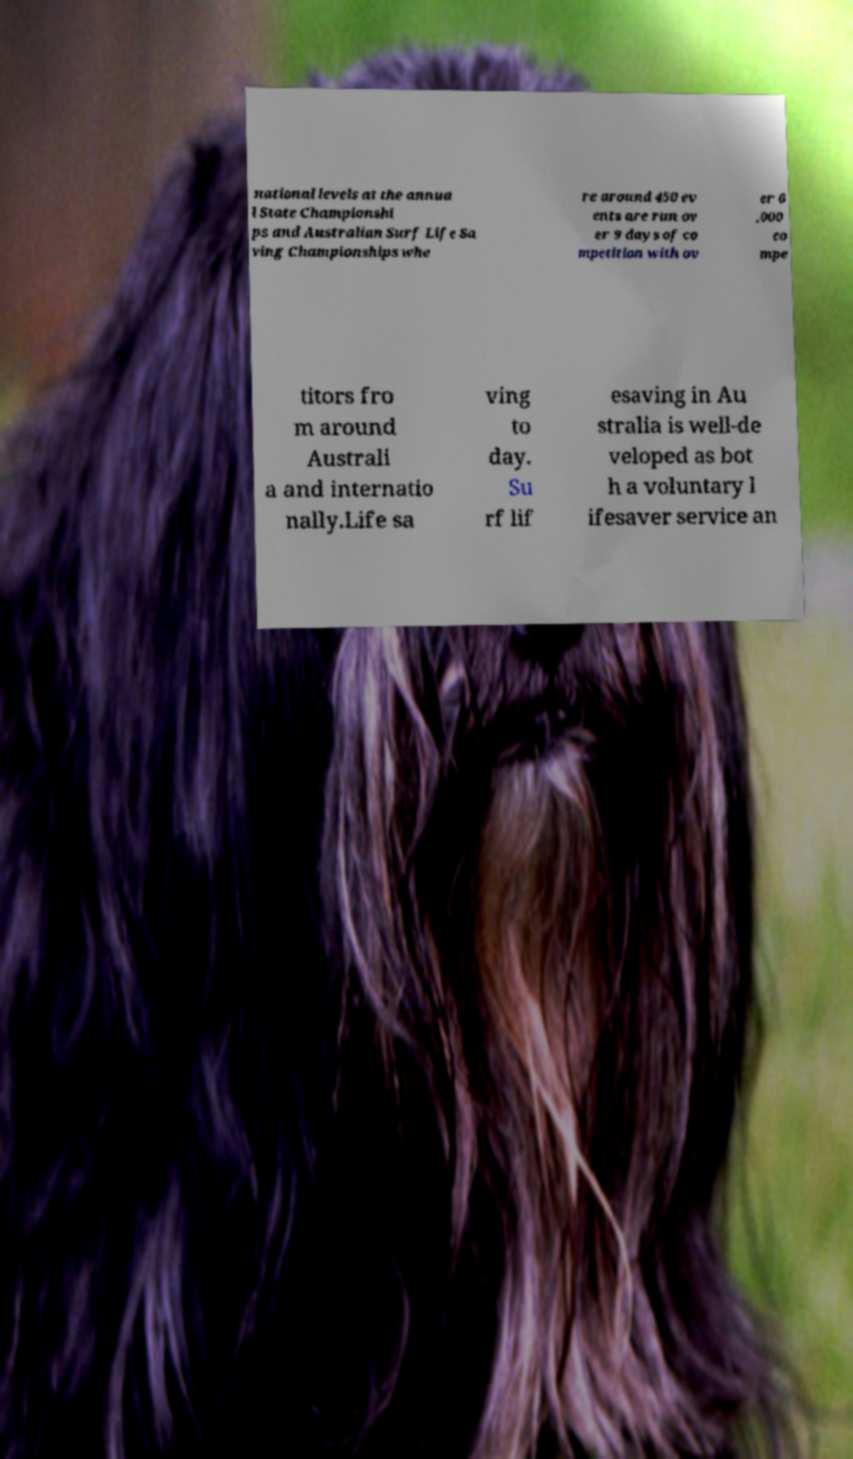What messages or text are displayed in this image? I need them in a readable, typed format. national levels at the annua l State Championshi ps and Australian Surf Life Sa ving Championships whe re around 450 ev ents are run ov er 9 days of co mpetition with ov er 6 ,000 co mpe titors fro m around Australi a and internatio nally.Life sa ving to day. Su rf lif esaving in Au stralia is well-de veloped as bot h a voluntary l ifesaver service an 